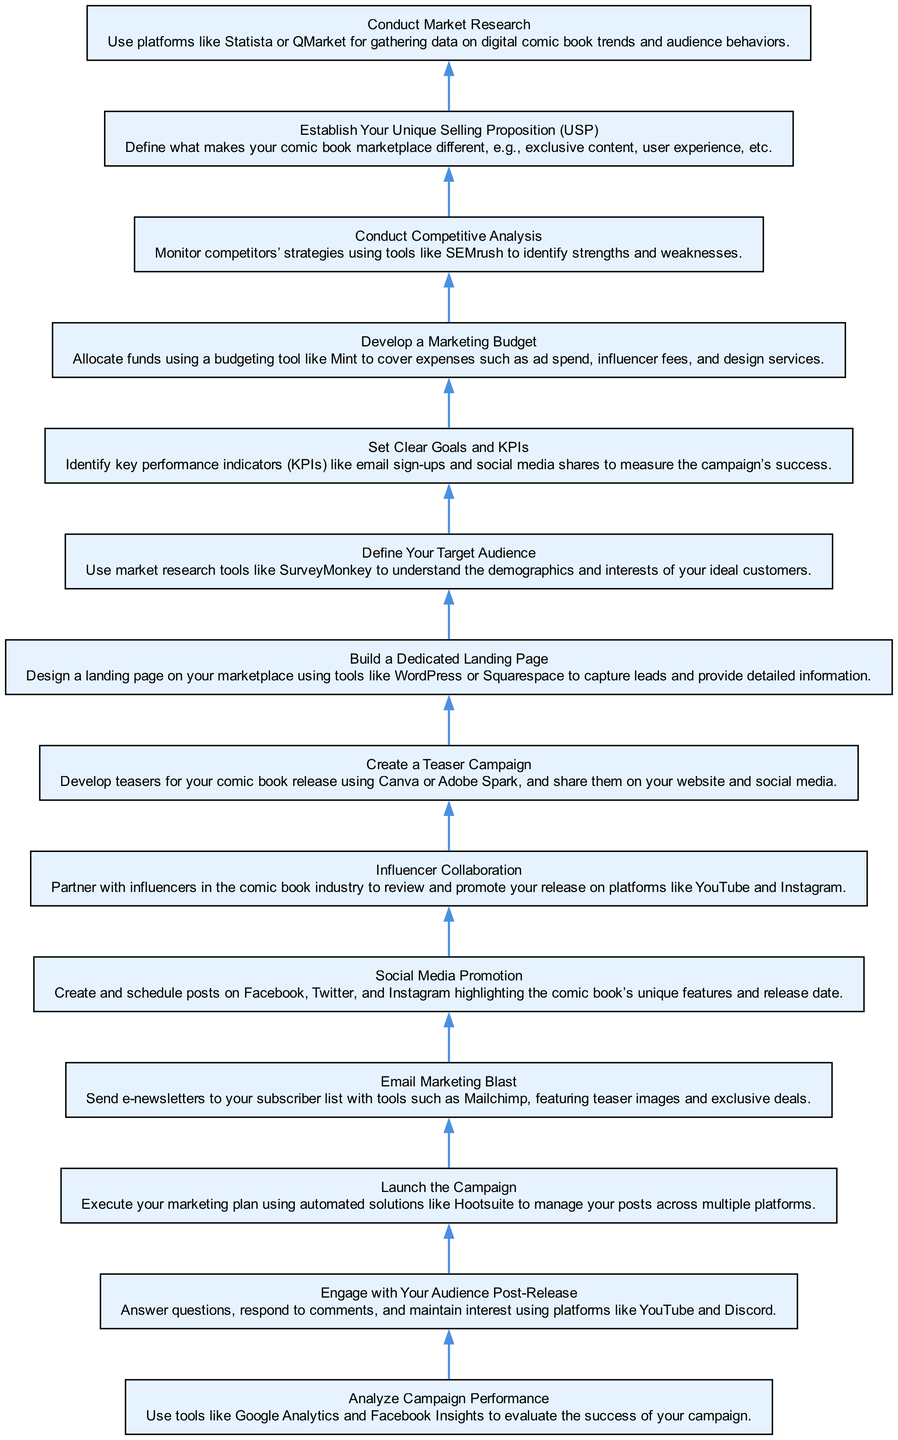What is the first step in the digital marketing campaign? The first step listed in the bottom node of the diagram is "Conduct Market Research." It is the starting point for gathering information on digital comic book trends and audience behaviors.
Answer: Conduct Market Research How many nodes are there in the diagram? The diagram contains a total of 14 nodes, each representing a specific step in the marketing campaign process. This includes both primary tasks and supporting actions.
Answer: 14 What does the last node of the flow chart indicate? The last node indicates "Analyze Campaign Performance." This shows that after launching the campaign and engaging with the audience, one should evaluate the effectiveness of the campaign using analytics tools.
Answer: Analyze Campaign Performance Which step involves sending e-newsletters? The step that involves sending e-newsletters is called "Email Marketing Blast." It focuses on communicating with subscribers with special offers and previews about the comic book.
Answer: Email Marketing Blast What is the relationship between "Define Your Target Audience" and "Set Clear Goals and KPIs"? "Define Your Target Audience" comes before "Set Clear Goals and KPIs" in the flow, as determining the audience is essential for establishing relevant goals and performance indicators for the campaign.
Answer: It is a preceding step Which step emphasizes building connections with influencers in the comic book industry? The step that emphasizes building connections with influencers is called "Influencer Collaboration." This is a strategic task for increasing visibility through partnerships.
Answer: Influencer Collaboration What is the step to create initial curiosity about the comic book? The step dedicated to creating curiosity is "Create a Teaser Campaign." It involves developing engaging promotional material beforehand to excite potential readers.
Answer: Create a Teaser Campaign How does the flowchart suggest you should manage posts across social media? The flowchart suggests using automated solutions like Hootsuite in the "Launch the Campaign" step to manage and schedule your posts effectively across various platforms.
Answer: Hootsuite 